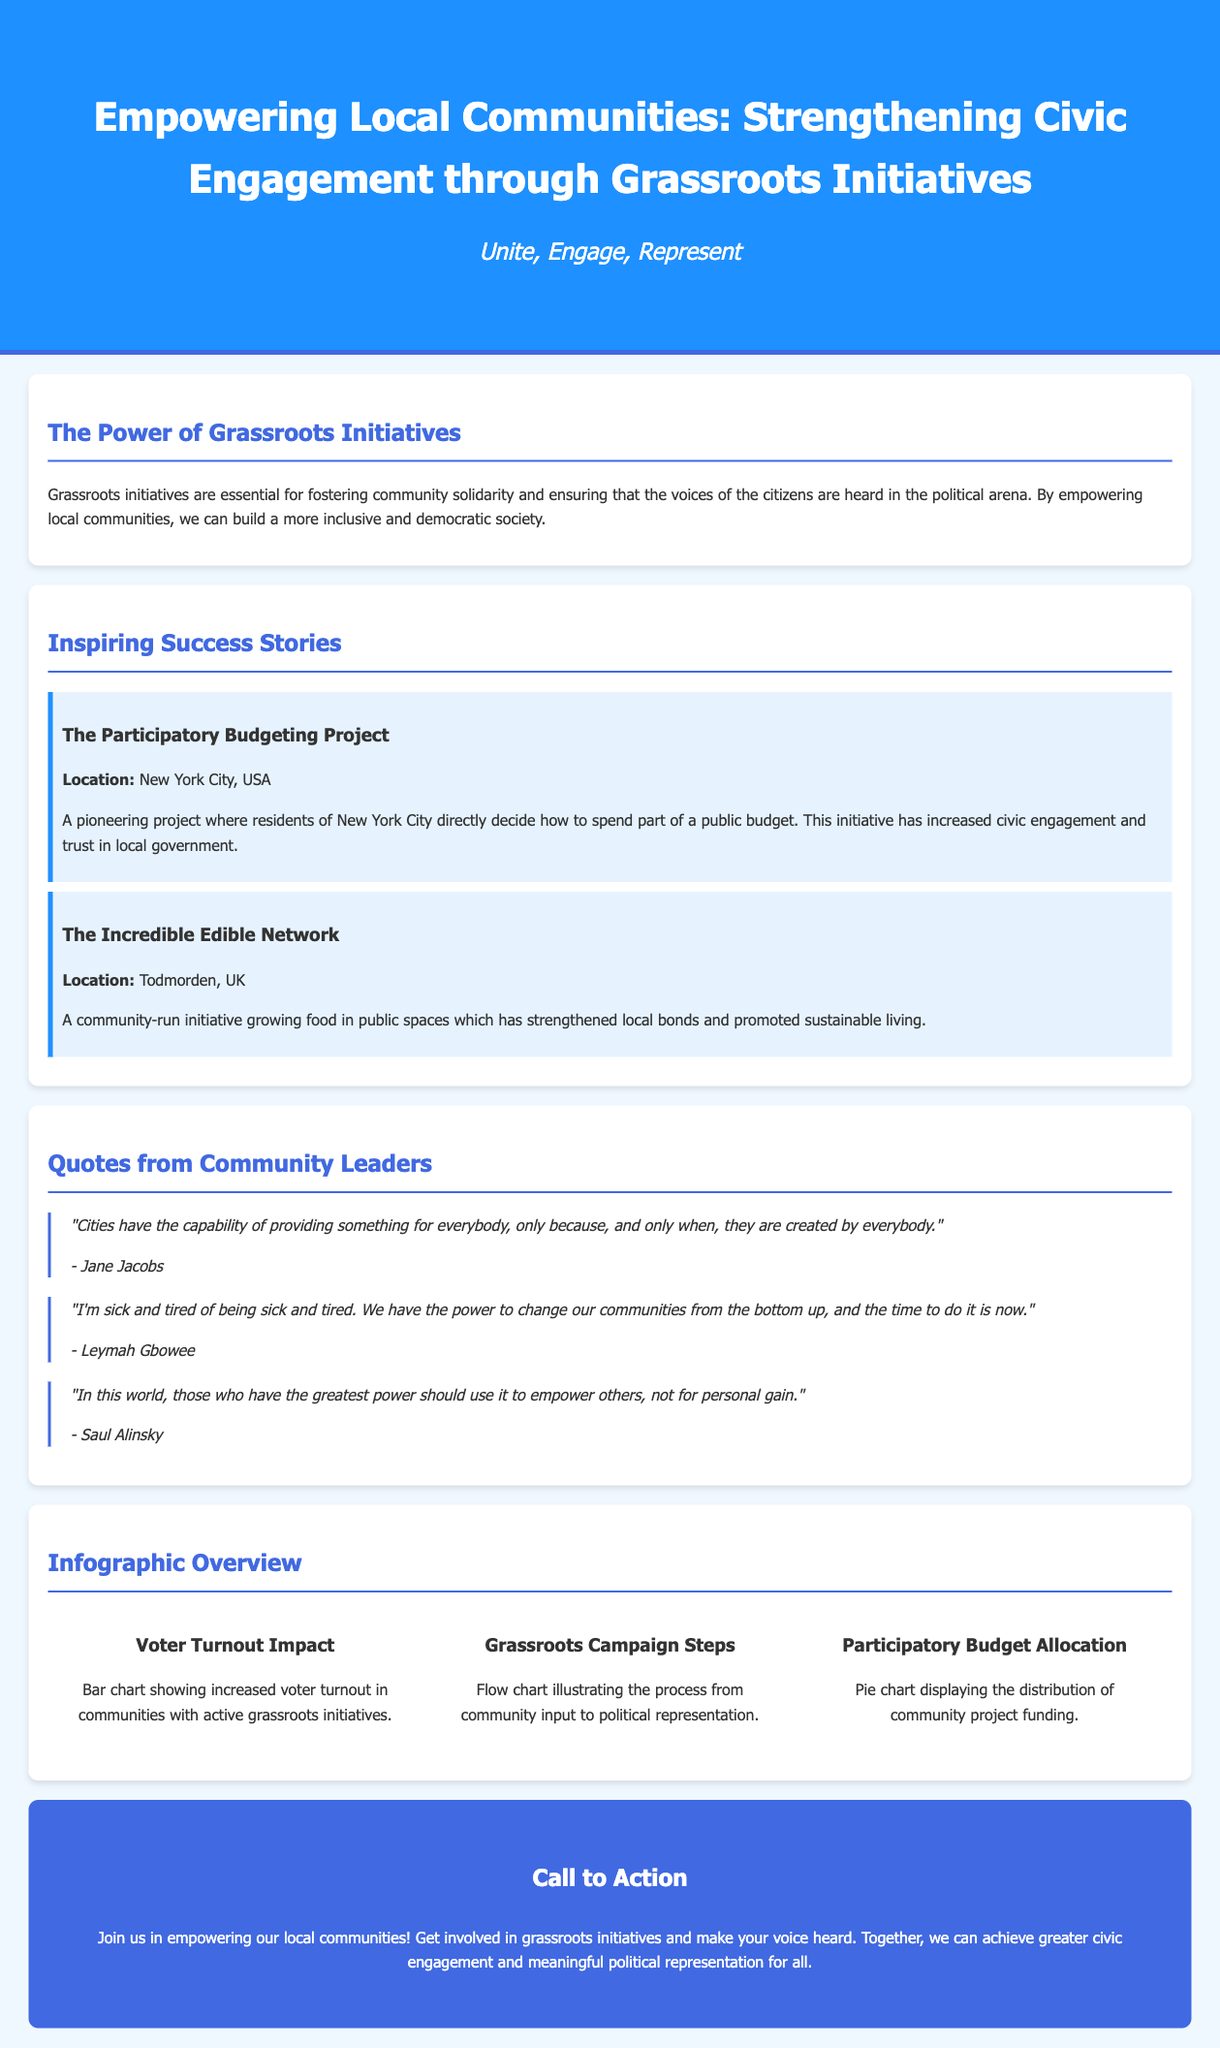What is the title of the document? The title is prominently displayed in the header section of the document, which is "Empowering Local Communities: Strengthening Civic Engagement through Grassroots Initiatives."
Answer: Empowering Local Communities: Strengthening Civic Engagement through Grassroots Initiatives What is the location of The Participatory Budgeting Project? The document specifies that this project is located in New York City, USA.
Answer: New York City, USA Who is quoted saying, "Cities have the capability of providing something for everybody"? This quote is attributed to Jane Jacobs, as mentioned in the Quotes section.
Answer: Jane Jacobs What does the pie chart in the infographic represent? The description of the pie chart states it displays the distribution of community project funding.
Answer: Distribution of community project funding What is the main purpose of grassroots initiatives according to the document? The text explains that grassroots initiatives are meant to empower local communities and foster civic engagement.
Answer: Empower local communities and foster civic engagement How many success stories are highlighted in the advertisement? There are two success stories presented in the document.
Answer: Two What is the flow chart in the infographic meant to illustrate? The flow chart illustrates the process from community input to political representation.
Answer: Process from community input to political representation What is the call to action encouraging readers to do? The call to action encourages readers to get involved in grassroots initiatives and make their voices heard.
Answer: Get involved in grassroots initiatives What phrase encapsulates the subheadline of the document? The subheadline is highlighted as "Unite, Engage, Represent."
Answer: Unite, Engage, Represent 